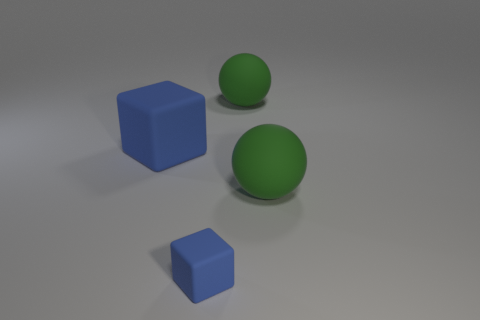Add 1 large green rubber spheres. How many objects exist? 5 Subtract all small rubber objects. Subtract all small yellow things. How many objects are left? 3 Add 4 blue rubber blocks. How many blue rubber blocks are left? 6 Add 3 big green things. How many big green things exist? 5 Subtract 0 cyan balls. How many objects are left? 4 